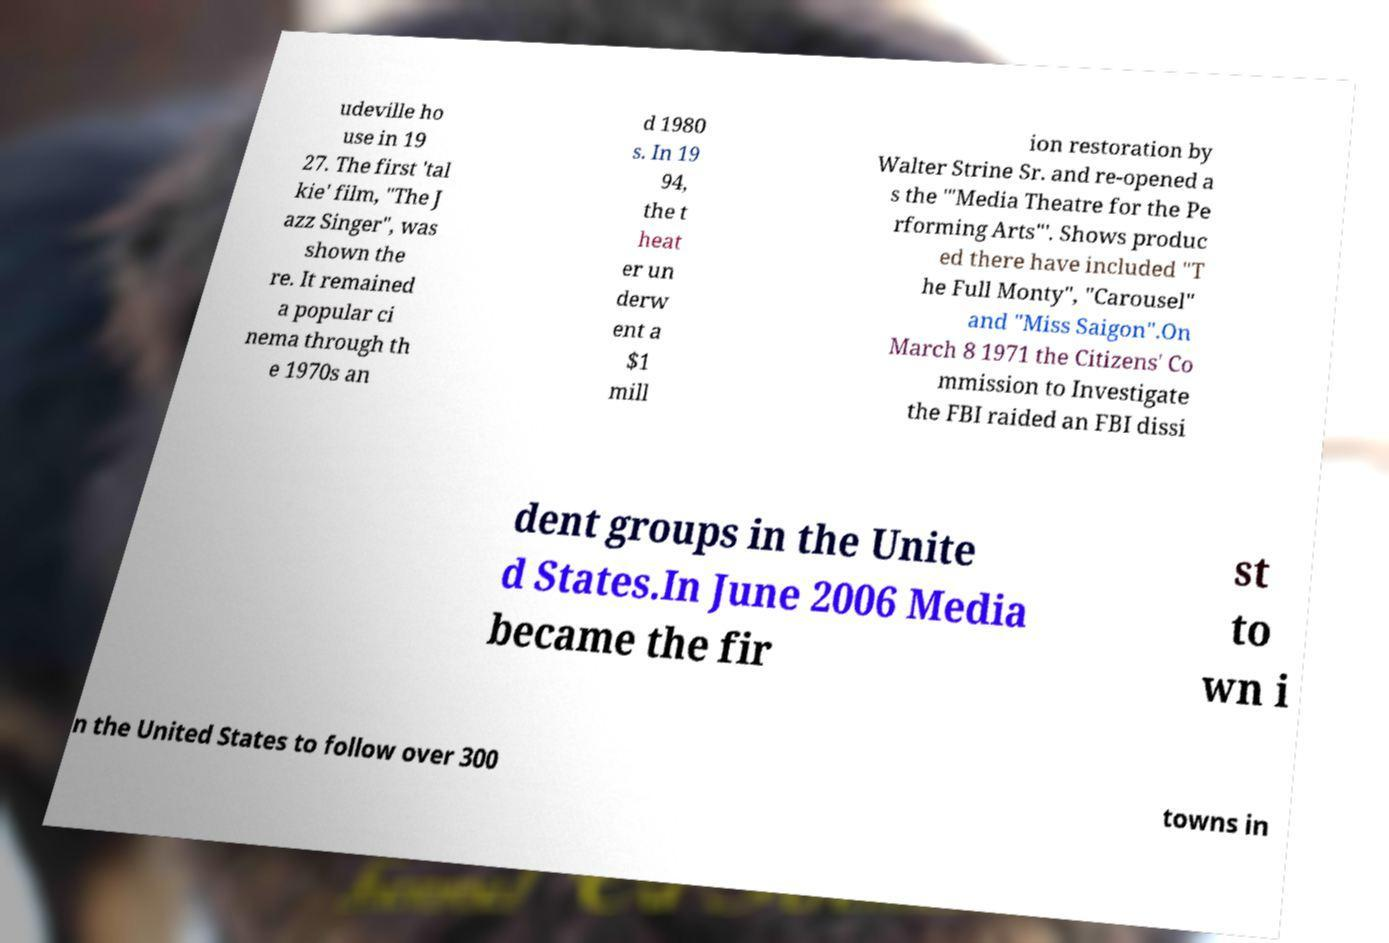For documentation purposes, I need the text within this image transcribed. Could you provide that? udeville ho use in 19 27. The first 'tal kie' film, "The J azz Singer", was shown the re. It remained a popular ci nema through th e 1970s an d 1980 s. In 19 94, the t heat er un derw ent a $1 mill ion restoration by Walter Strine Sr. and re-opened a s the '"Media Theatre for the Pe rforming Arts"'. Shows produc ed there have included "T he Full Monty", "Carousel" and "Miss Saigon".On March 8 1971 the Citizens' Co mmission to Investigate the FBI raided an FBI dissi dent groups in the Unite d States.In June 2006 Media became the fir st to wn i n the United States to follow over 300 towns in 